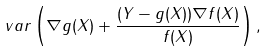Convert formula to latex. <formula><loc_0><loc_0><loc_500><loc_500>\ v a r \left ( \nabla g ( X ) + \frac { ( Y - g ( X ) ) \nabla f ( X ) } { f ( X ) } \right ) ,</formula> 